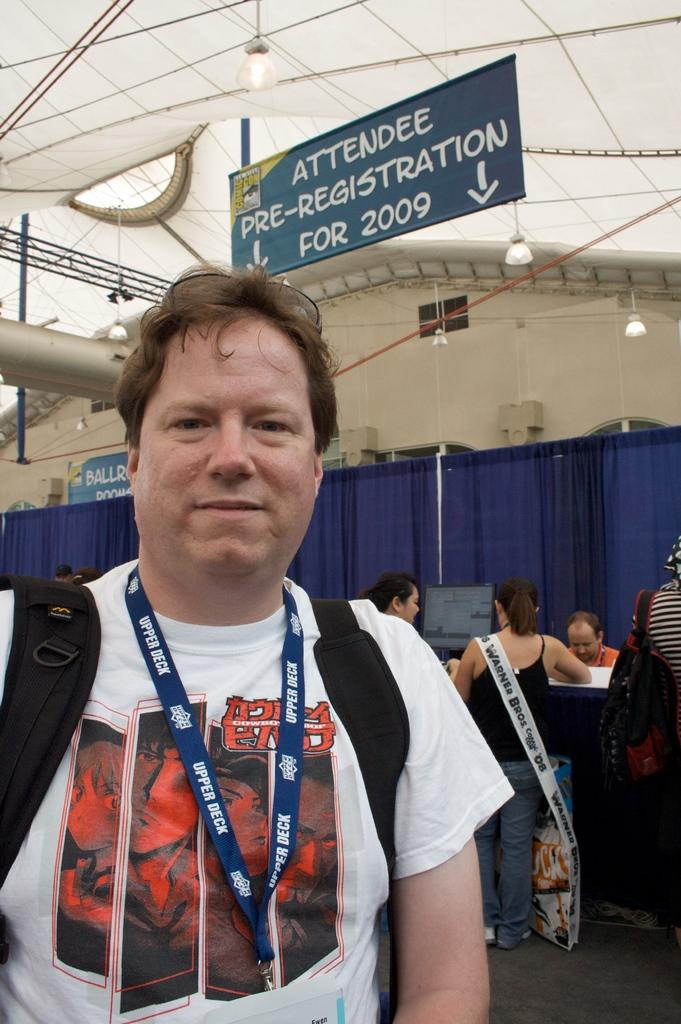<image>
Present a compact description of the photo's key features. A sign stating Attendee Pre Registration for 2009. 